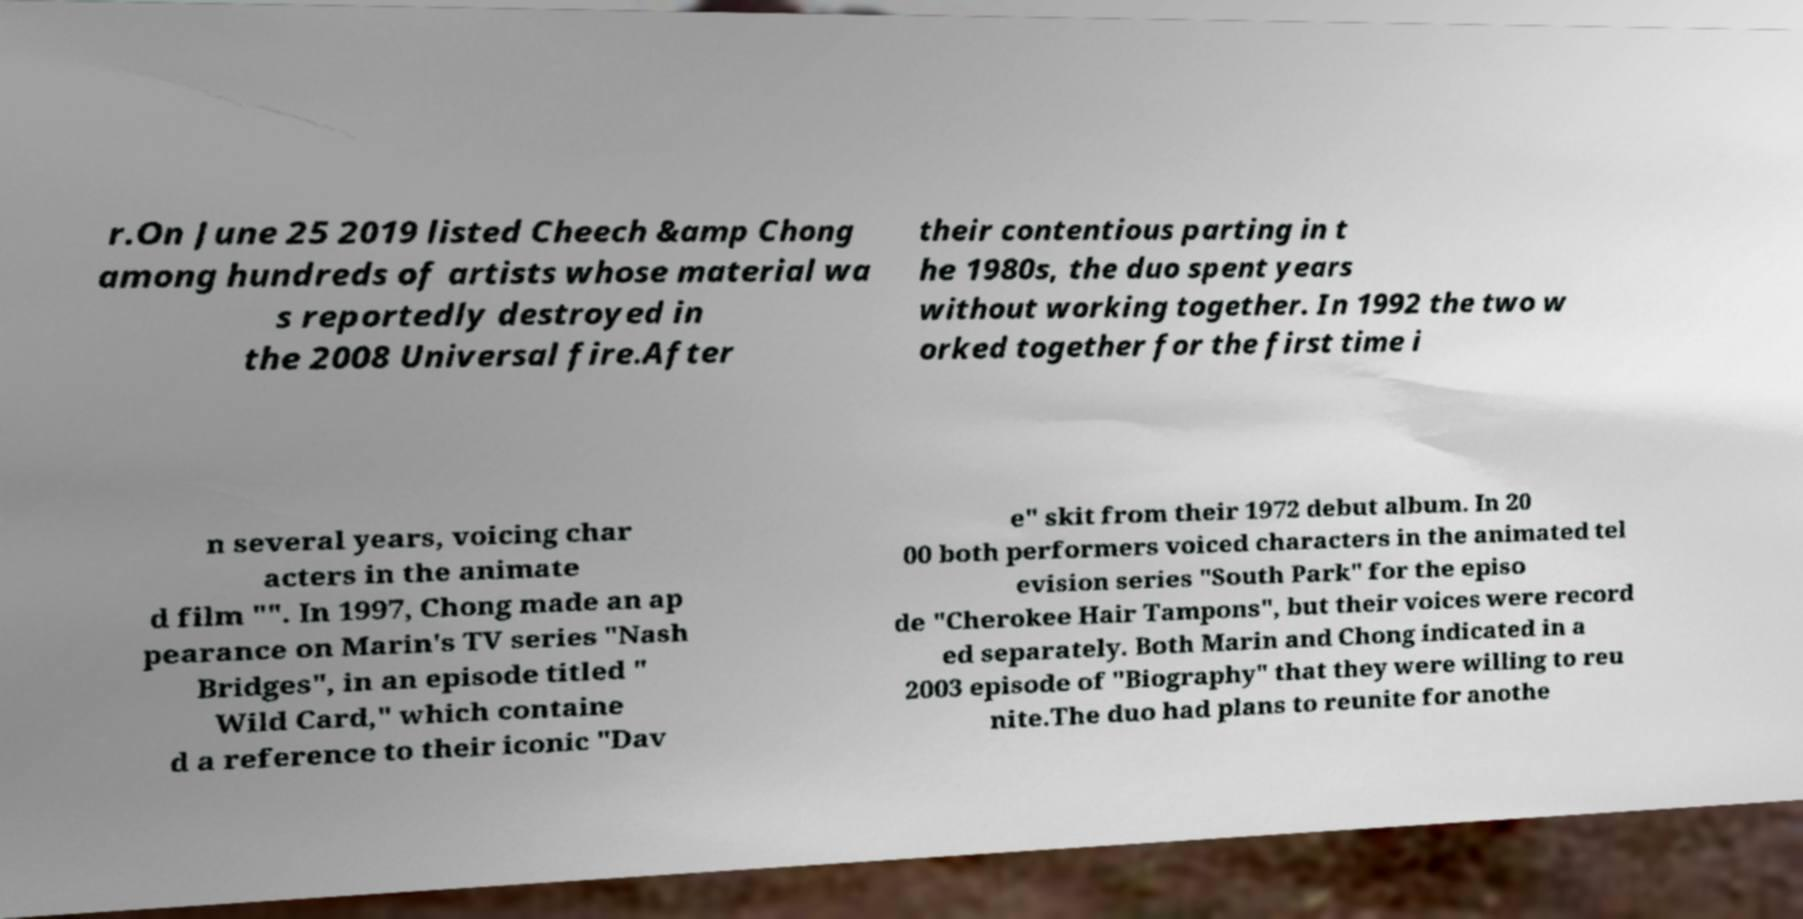Can you accurately transcribe the text from the provided image for me? r.On June 25 2019 listed Cheech &amp Chong among hundreds of artists whose material wa s reportedly destroyed in the 2008 Universal fire.After their contentious parting in t he 1980s, the duo spent years without working together. In 1992 the two w orked together for the first time i n several years, voicing char acters in the animate d film "". In 1997, Chong made an ap pearance on Marin's TV series "Nash Bridges", in an episode titled " Wild Card," which containe d a reference to their iconic "Dav e" skit from their 1972 debut album. In 20 00 both performers voiced characters in the animated tel evision series "South Park" for the episo de "Cherokee Hair Tampons", but their voices were record ed separately. Both Marin and Chong indicated in a 2003 episode of "Biography" that they were willing to reu nite.The duo had plans to reunite for anothe 